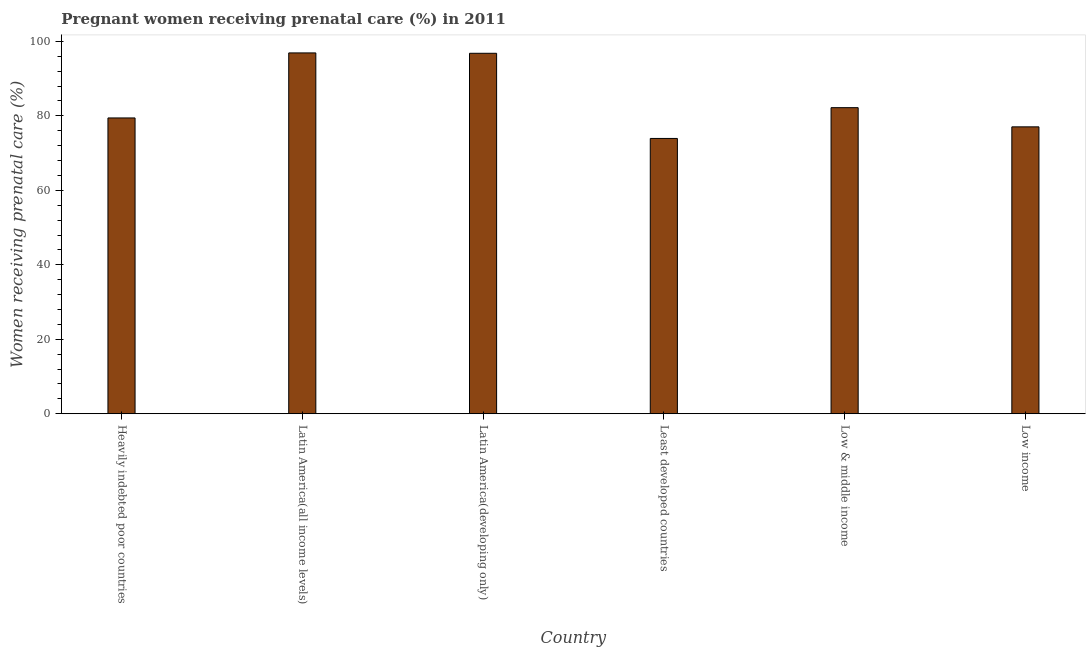Does the graph contain any zero values?
Provide a succinct answer. No. Does the graph contain grids?
Offer a terse response. No. What is the title of the graph?
Keep it short and to the point. Pregnant women receiving prenatal care (%) in 2011. What is the label or title of the X-axis?
Ensure brevity in your answer.  Country. What is the label or title of the Y-axis?
Your answer should be compact. Women receiving prenatal care (%). What is the percentage of pregnant women receiving prenatal care in Latin America(all income levels)?
Give a very brief answer. 96.9. Across all countries, what is the maximum percentage of pregnant women receiving prenatal care?
Your response must be concise. 96.9. Across all countries, what is the minimum percentage of pregnant women receiving prenatal care?
Make the answer very short. 73.93. In which country was the percentage of pregnant women receiving prenatal care maximum?
Keep it short and to the point. Latin America(all income levels). In which country was the percentage of pregnant women receiving prenatal care minimum?
Your response must be concise. Least developed countries. What is the sum of the percentage of pregnant women receiving prenatal care?
Make the answer very short. 506.31. What is the difference between the percentage of pregnant women receiving prenatal care in Latin America(developing only) and Low income?
Your response must be concise. 19.75. What is the average percentage of pregnant women receiving prenatal care per country?
Offer a terse response. 84.39. What is the median percentage of pregnant women receiving prenatal care?
Provide a succinct answer. 80.82. In how many countries, is the percentage of pregnant women receiving prenatal care greater than 4 %?
Make the answer very short. 6. What is the ratio of the percentage of pregnant women receiving prenatal care in Heavily indebted poor countries to that in Latin America(all income levels)?
Offer a very short reply. 0.82. Is the difference between the percentage of pregnant women receiving prenatal care in Least developed countries and Low & middle income greater than the difference between any two countries?
Your answer should be very brief. No. What is the difference between the highest and the second highest percentage of pregnant women receiving prenatal care?
Your response must be concise. 0.1. Is the sum of the percentage of pregnant women receiving prenatal care in Heavily indebted poor countries and Least developed countries greater than the maximum percentage of pregnant women receiving prenatal care across all countries?
Keep it short and to the point. Yes. What is the difference between the highest and the lowest percentage of pregnant women receiving prenatal care?
Make the answer very short. 22.97. In how many countries, is the percentage of pregnant women receiving prenatal care greater than the average percentage of pregnant women receiving prenatal care taken over all countries?
Your response must be concise. 2. How many bars are there?
Provide a short and direct response. 6. Are all the bars in the graph horizontal?
Your answer should be compact. No. How many countries are there in the graph?
Your response must be concise. 6. What is the difference between two consecutive major ticks on the Y-axis?
Provide a short and direct response. 20. What is the Women receiving prenatal care (%) in Heavily indebted poor countries?
Your answer should be very brief. 79.44. What is the Women receiving prenatal care (%) of Latin America(all income levels)?
Offer a very short reply. 96.9. What is the Women receiving prenatal care (%) in Latin America(developing only)?
Make the answer very short. 96.8. What is the Women receiving prenatal care (%) in Least developed countries?
Your answer should be very brief. 73.93. What is the Women receiving prenatal care (%) of Low & middle income?
Offer a terse response. 82.2. What is the Women receiving prenatal care (%) in Low income?
Your answer should be compact. 77.05. What is the difference between the Women receiving prenatal care (%) in Heavily indebted poor countries and Latin America(all income levels)?
Keep it short and to the point. -17.46. What is the difference between the Women receiving prenatal care (%) in Heavily indebted poor countries and Latin America(developing only)?
Your response must be concise. -17.36. What is the difference between the Women receiving prenatal care (%) in Heavily indebted poor countries and Least developed countries?
Ensure brevity in your answer.  5.5. What is the difference between the Women receiving prenatal care (%) in Heavily indebted poor countries and Low & middle income?
Your response must be concise. -2.76. What is the difference between the Women receiving prenatal care (%) in Heavily indebted poor countries and Low income?
Make the answer very short. 2.39. What is the difference between the Women receiving prenatal care (%) in Latin America(all income levels) and Latin America(developing only)?
Your answer should be very brief. 0.1. What is the difference between the Women receiving prenatal care (%) in Latin America(all income levels) and Least developed countries?
Give a very brief answer. 22.97. What is the difference between the Women receiving prenatal care (%) in Latin America(all income levels) and Low & middle income?
Ensure brevity in your answer.  14.7. What is the difference between the Women receiving prenatal care (%) in Latin America(all income levels) and Low income?
Offer a very short reply. 19.85. What is the difference between the Women receiving prenatal care (%) in Latin America(developing only) and Least developed countries?
Ensure brevity in your answer.  22.87. What is the difference between the Women receiving prenatal care (%) in Latin America(developing only) and Low & middle income?
Offer a terse response. 14.6. What is the difference between the Women receiving prenatal care (%) in Latin America(developing only) and Low income?
Give a very brief answer. 19.75. What is the difference between the Women receiving prenatal care (%) in Least developed countries and Low & middle income?
Offer a very short reply. -8.26. What is the difference between the Women receiving prenatal care (%) in Least developed countries and Low income?
Keep it short and to the point. -3.11. What is the difference between the Women receiving prenatal care (%) in Low & middle income and Low income?
Offer a very short reply. 5.15. What is the ratio of the Women receiving prenatal care (%) in Heavily indebted poor countries to that in Latin America(all income levels)?
Make the answer very short. 0.82. What is the ratio of the Women receiving prenatal care (%) in Heavily indebted poor countries to that in Latin America(developing only)?
Provide a short and direct response. 0.82. What is the ratio of the Women receiving prenatal care (%) in Heavily indebted poor countries to that in Least developed countries?
Ensure brevity in your answer.  1.07. What is the ratio of the Women receiving prenatal care (%) in Heavily indebted poor countries to that in Low income?
Give a very brief answer. 1.03. What is the ratio of the Women receiving prenatal care (%) in Latin America(all income levels) to that in Least developed countries?
Offer a terse response. 1.31. What is the ratio of the Women receiving prenatal care (%) in Latin America(all income levels) to that in Low & middle income?
Your answer should be very brief. 1.18. What is the ratio of the Women receiving prenatal care (%) in Latin America(all income levels) to that in Low income?
Provide a short and direct response. 1.26. What is the ratio of the Women receiving prenatal care (%) in Latin America(developing only) to that in Least developed countries?
Make the answer very short. 1.31. What is the ratio of the Women receiving prenatal care (%) in Latin America(developing only) to that in Low & middle income?
Your answer should be very brief. 1.18. What is the ratio of the Women receiving prenatal care (%) in Latin America(developing only) to that in Low income?
Make the answer very short. 1.26. What is the ratio of the Women receiving prenatal care (%) in Least developed countries to that in Low & middle income?
Provide a succinct answer. 0.9. What is the ratio of the Women receiving prenatal care (%) in Low & middle income to that in Low income?
Provide a short and direct response. 1.07. 